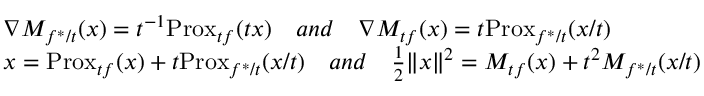Convert formula to latex. <formula><loc_0><loc_0><loc_500><loc_500>\begin{array} { r l } & { \nabla M _ { f ^ { * } / t } ( x ) = t ^ { - 1 } P r o x _ { t f } ( t x ) \quad a n d \quad \nabla M _ { t f } ( x ) = t P r o x _ { f ^ { * } / t } ( x / t ) } \\ & { x = P r o x _ { t f } ( x ) + t P r o x _ { f ^ { * } / t } ( x / t ) \quad a n d \quad \frac { 1 } { 2 } \| x \| ^ { 2 } = M _ { t f } ( x ) + t ^ { 2 } M _ { f ^ { * } / t } ( x / t ) } \end{array}</formula> 